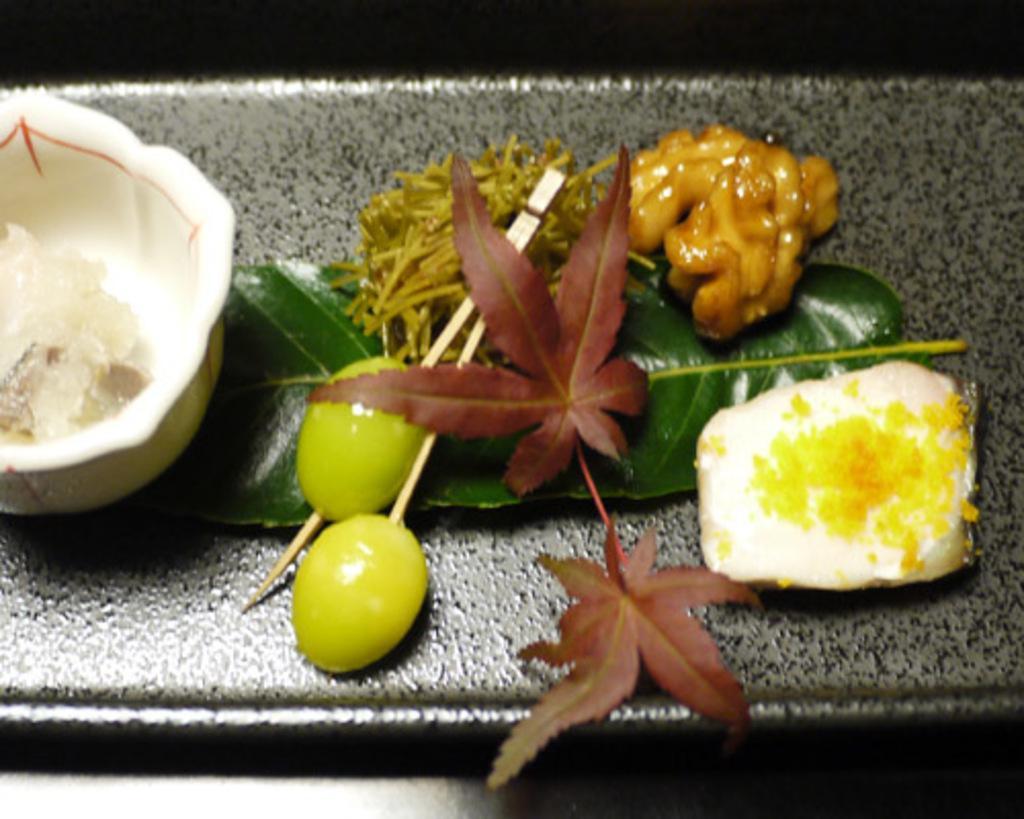Could you give a brief overview of what you see in this image? In the image there are fruits, leaves and some other items kept on a surface. 